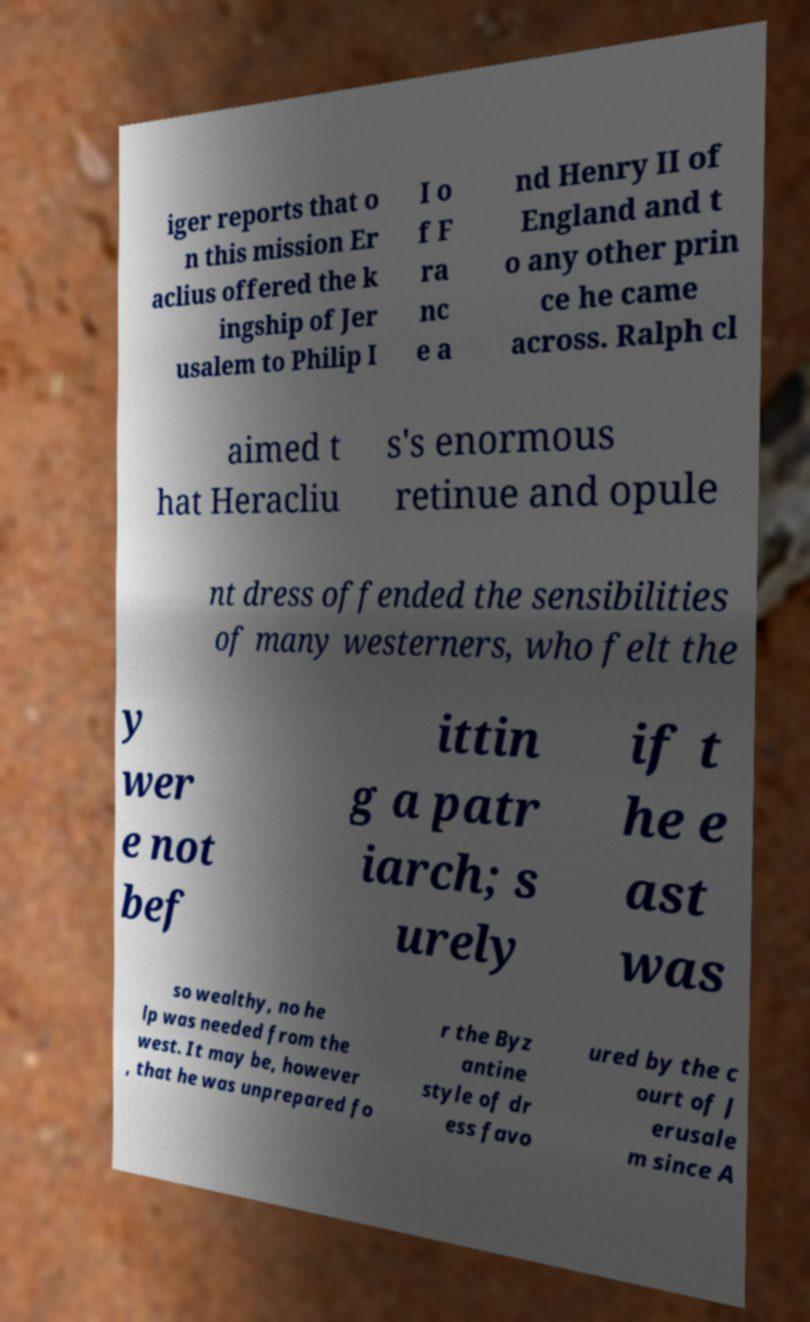Can you accurately transcribe the text from the provided image for me? iger reports that o n this mission Er aclius offered the k ingship of Jer usalem to Philip I I o f F ra nc e a nd Henry II of England and t o any other prin ce he came across. Ralph cl aimed t hat Heracliu s's enormous retinue and opule nt dress offended the sensibilities of many westerners, who felt the y wer e not bef ittin g a patr iarch; s urely if t he e ast was so wealthy, no he lp was needed from the west. It may be, however , that he was unprepared fo r the Byz antine style of dr ess favo ured by the c ourt of J erusale m since A 